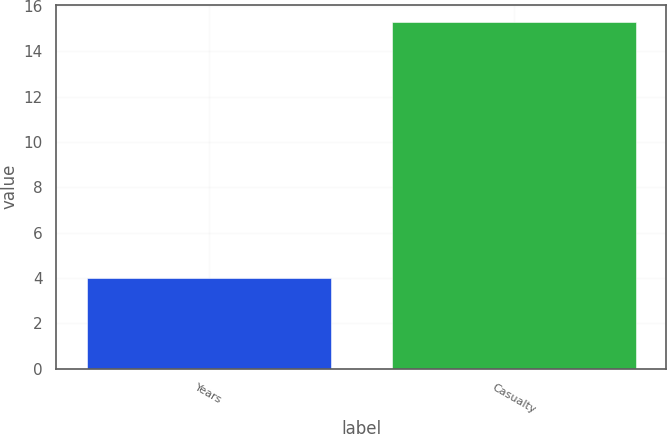<chart> <loc_0><loc_0><loc_500><loc_500><bar_chart><fcel>Years<fcel>Casualty<nl><fcel>4<fcel>15.3<nl></chart> 